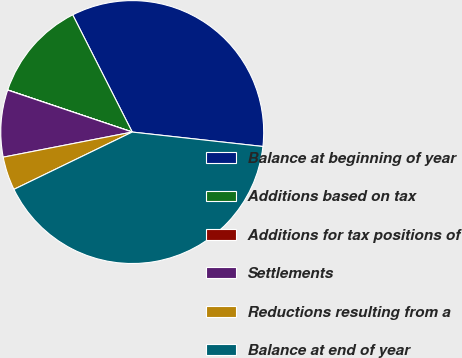<chart> <loc_0><loc_0><loc_500><loc_500><pie_chart><fcel>Balance at beginning of year<fcel>Additions based on tax<fcel>Additions for tax positions of<fcel>Settlements<fcel>Reductions resulting from a<fcel>Balance at end of year<nl><fcel>34.23%<fcel>12.33%<fcel>0.02%<fcel>8.23%<fcel>4.12%<fcel>41.07%<nl></chart> 